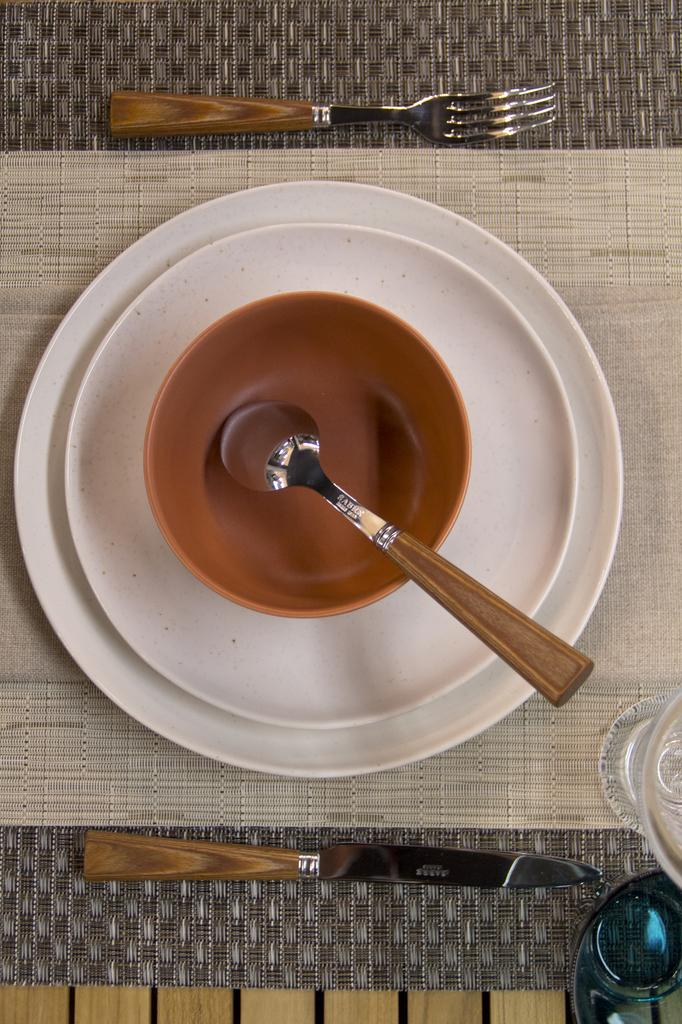What is in the bowl in the image? There is a spoon in a bowl in the image. Where is the spoon located in relation to the bowl? The spoon is in the bowl. What other items can be seen in the image besides the spoon and bowl? There are plates, a knife, a fork, and glasses in the image. Where are these items placed in the image? The spoon, plates, knife, fork, and glasses are on a platform. What type of powder is being used to clean the wax off the plates in the image? There is no powder or wax present in the image; it only shows a spoon in a bowl and other tableware items on a platform. 